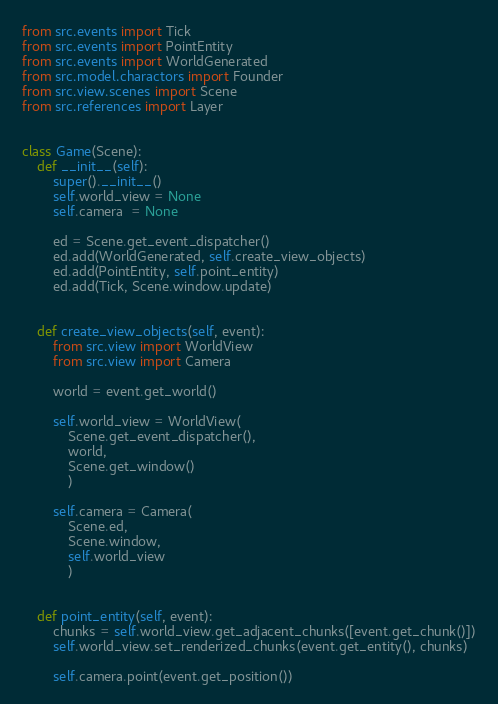Convert code to text. <code><loc_0><loc_0><loc_500><loc_500><_Python_>from src.events import Tick
from src.events import PointEntity
from src.events import WorldGenerated
from src.model.charactors import Founder
from src.view.scenes import Scene
from src.references import Layer


class Game(Scene):
    def __init__(self):
        super().__init__()
        self.world_view = None
        self.camera  = None

        ed = Scene.get_event_dispatcher()
        ed.add(WorldGenerated, self.create_view_objects)
        ed.add(PointEntity, self.point_entity)
        ed.add(Tick, Scene.window.update)


    def create_view_objects(self, event):
        from src.view import WorldView
        from src.view import Camera

        world = event.get_world()

        self.world_view = WorldView(
            Scene.get_event_dispatcher(),
            world,
            Scene.get_window()
            )

        self.camera = Camera(
            Scene.ed,
            Scene.window,
            self.world_view
            )


    def point_entity(self, event):
        chunks = self.world_view.get_adjacent_chunks([event.get_chunk()])
        self.world_view.set_renderized_chunks(event.get_entity(), chunks)
        
        self.camera.point(event.get_position())</code> 